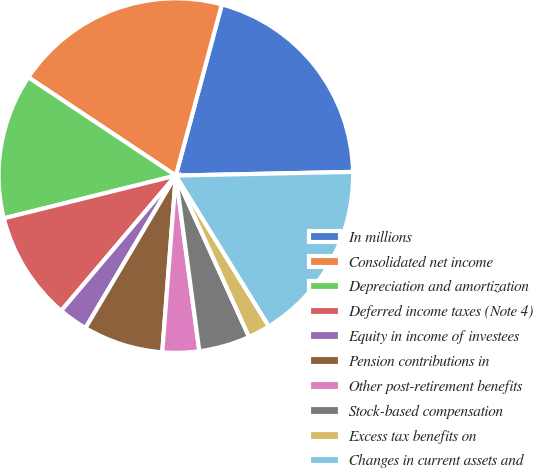<chart> <loc_0><loc_0><loc_500><loc_500><pie_chart><fcel>In millions<fcel>Consolidated net income<fcel>Depreciation and amortization<fcel>Deferred income taxes (Note 4)<fcel>Equity in income of investees<fcel>Pension contributions in<fcel>Other post-retirement benefits<fcel>Stock-based compensation<fcel>Excess tax benefits on<fcel>Changes in current assets and<nl><fcel>20.49%<fcel>19.83%<fcel>13.23%<fcel>9.93%<fcel>2.68%<fcel>7.29%<fcel>3.34%<fcel>4.66%<fcel>2.02%<fcel>16.53%<nl></chart> 